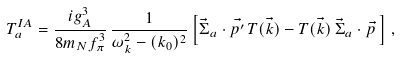<formula> <loc_0><loc_0><loc_500><loc_500>T ^ { I A } _ { a } = \frac { i g _ { A } ^ { 3 } } { 8 m _ { N } f _ { \pi } ^ { 3 } } \, \frac { 1 } { \omega _ { k } ^ { 2 } - ( k _ { 0 } ) ^ { 2 } } \left [ \vec { \Sigma } _ { a } \cdot \vec { p ^ { \prime } } \, T ( \vec { k } ) - T ( \vec { k } ) \, \vec { \Sigma } _ { a } \cdot \vec { p } \, \right ] \, ,</formula> 